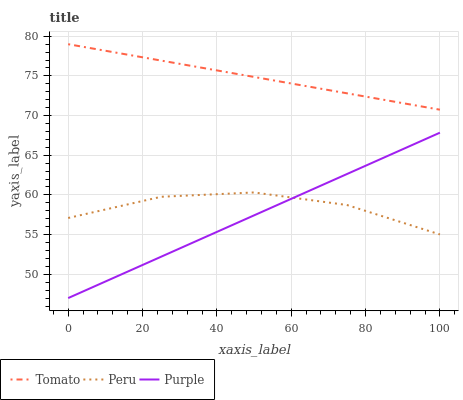Does Purple have the minimum area under the curve?
Answer yes or no. Yes. Does Tomato have the maximum area under the curve?
Answer yes or no. Yes. Does Peru have the minimum area under the curve?
Answer yes or no. No. Does Peru have the maximum area under the curve?
Answer yes or no. No. Is Tomato the smoothest?
Answer yes or no. Yes. Is Peru the roughest?
Answer yes or no. Yes. Is Peru the smoothest?
Answer yes or no. No. Is Purple the roughest?
Answer yes or no. No. Does Purple have the lowest value?
Answer yes or no. Yes. Does Peru have the lowest value?
Answer yes or no. No. Does Tomato have the highest value?
Answer yes or no. Yes. Does Purple have the highest value?
Answer yes or no. No. Is Purple less than Tomato?
Answer yes or no. Yes. Is Tomato greater than Purple?
Answer yes or no. Yes. Does Purple intersect Peru?
Answer yes or no. Yes. Is Purple less than Peru?
Answer yes or no. No. Is Purple greater than Peru?
Answer yes or no. No. Does Purple intersect Tomato?
Answer yes or no. No. 